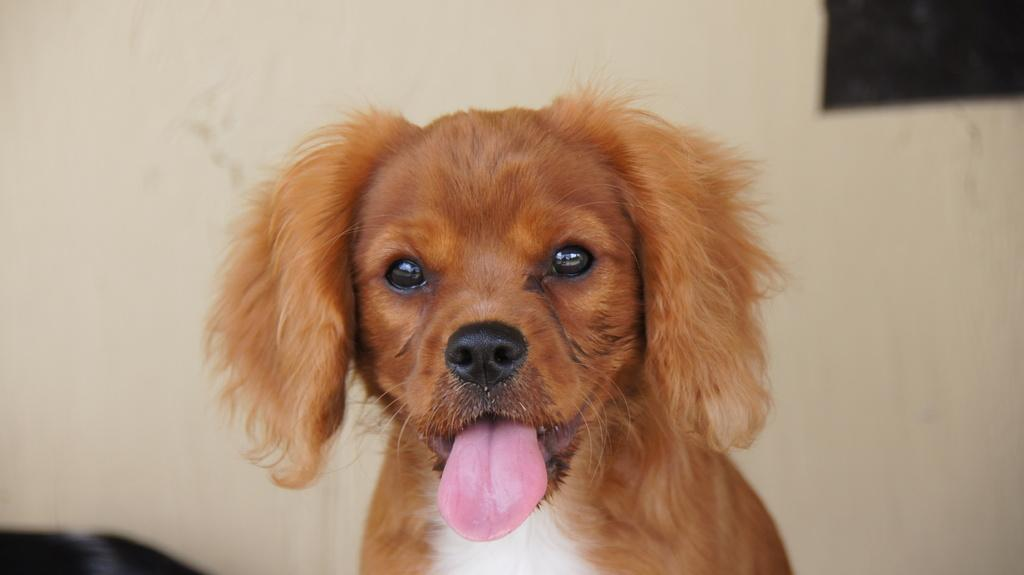What is the main subject of the image? There is a dog in the center of the image. Can you describe the appearance of the dog? The dog is brown and white in color. What can be observed about the background of the image? The background of the image is blurred. What type of cable is being used to control the dog's movements in the image? There is no cable present in the image, and the dog's movements are not controlled by any external force. 